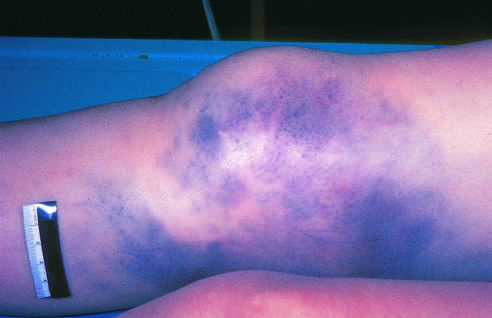has the alveolar spaces and blood vessels produced extensive discoloration?
Answer the question using a single word or phrase. No 